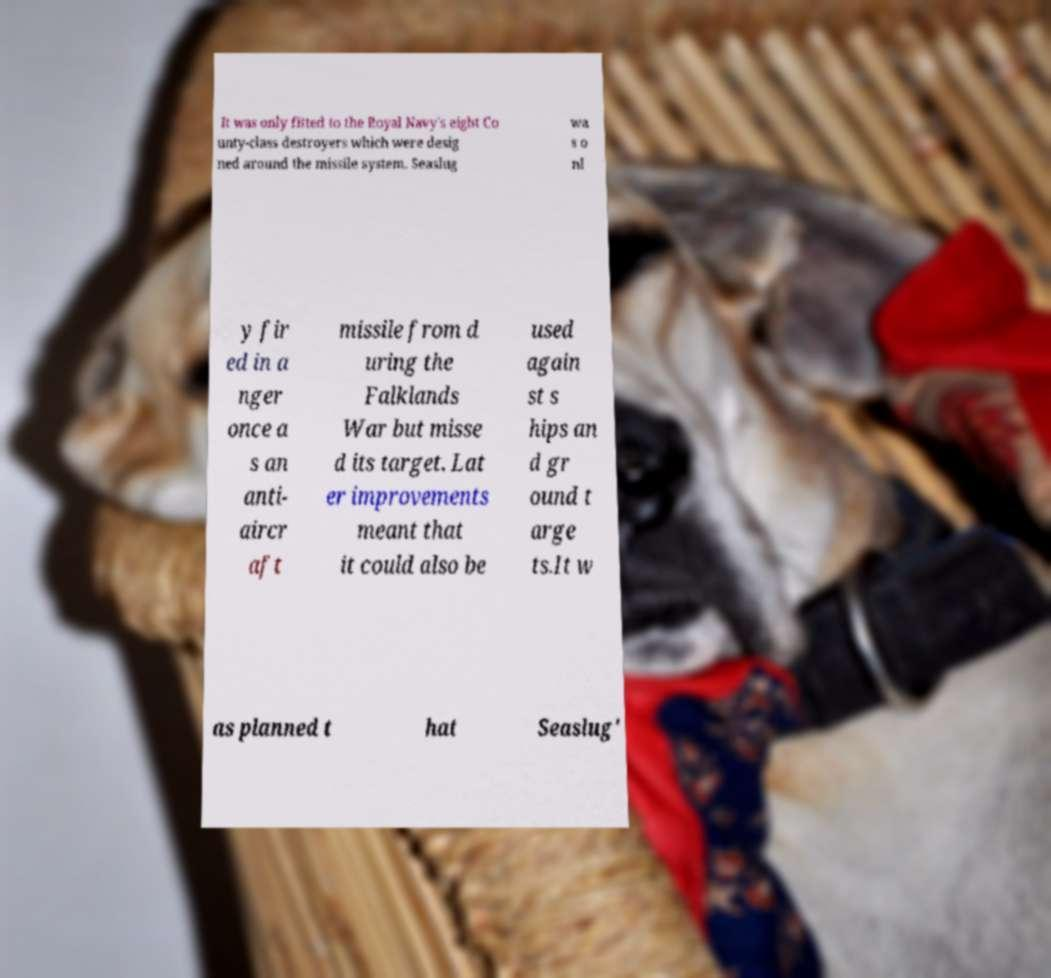Could you extract and type out the text from this image? It was only fitted to the Royal Navy's eight Co unty-class destroyers which were desig ned around the missile system. Seaslug wa s o nl y fir ed in a nger once a s an anti- aircr aft missile from d uring the Falklands War but misse d its target. Lat er improvements meant that it could also be used again st s hips an d gr ound t arge ts.It w as planned t hat Seaslug' 